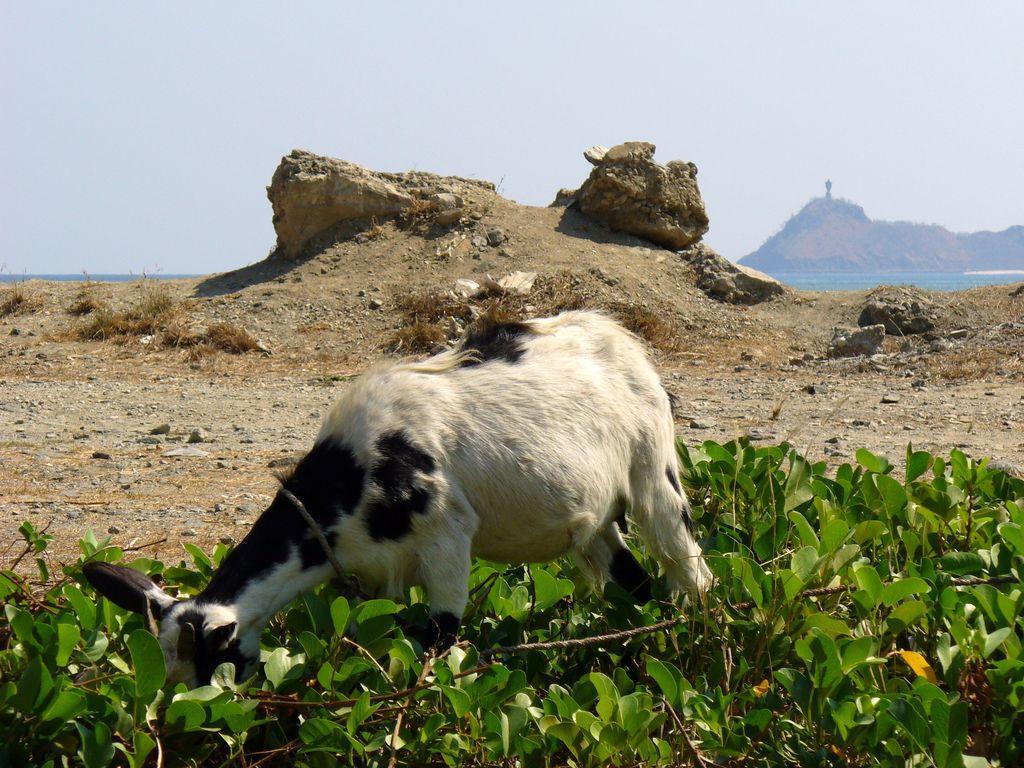In one or two sentences, can you explain what this image depicts? In this image I can see an animal eating the plants. I can see the stones. At the top I can see the sky. 